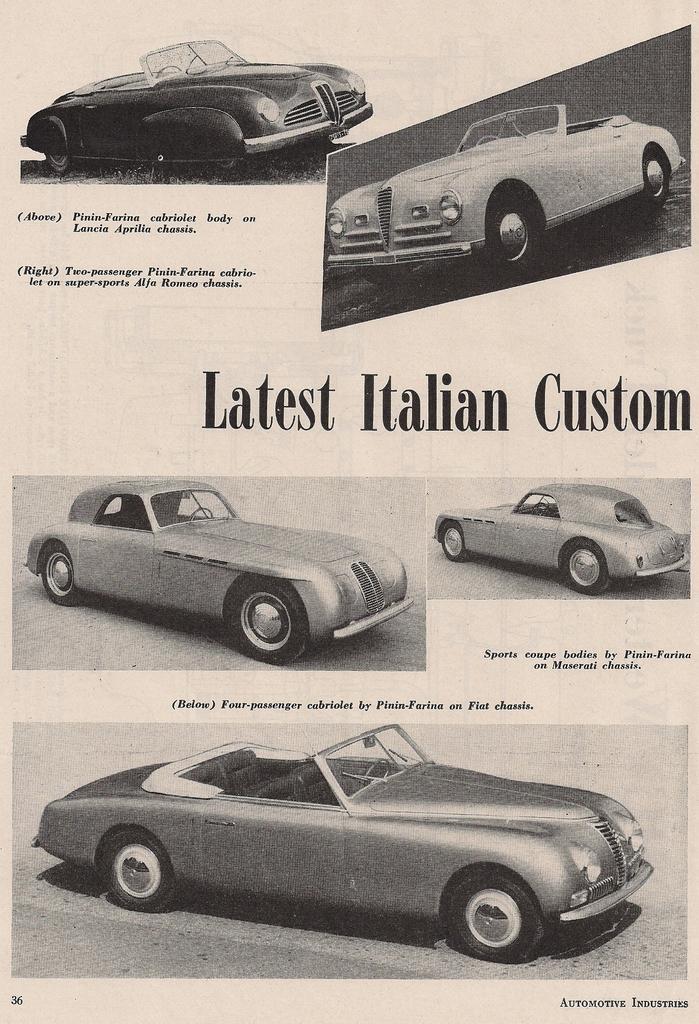Describe this image in one or two sentences. In this image I can see the paper. On the paper I can see few different cars and the text written on it. 